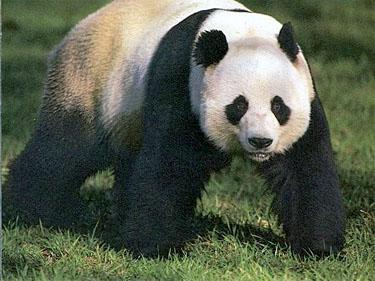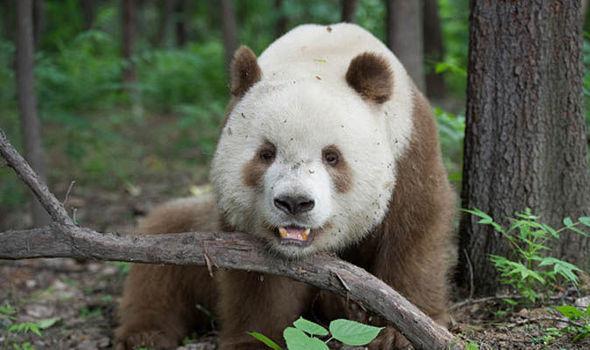The first image is the image on the left, the second image is the image on the right. Evaluate the accuracy of this statement regarding the images: "A panda has its chin on a surface.". Is it true? Answer yes or no. Yes. The first image is the image on the left, the second image is the image on the right. Given the left and right images, does the statement "There are a total of three panda bears in these images." hold true? Answer yes or no. No. The first image is the image on the left, the second image is the image on the right. Given the left and right images, does the statement "There are three panda bears" hold true? Answer yes or no. No. 